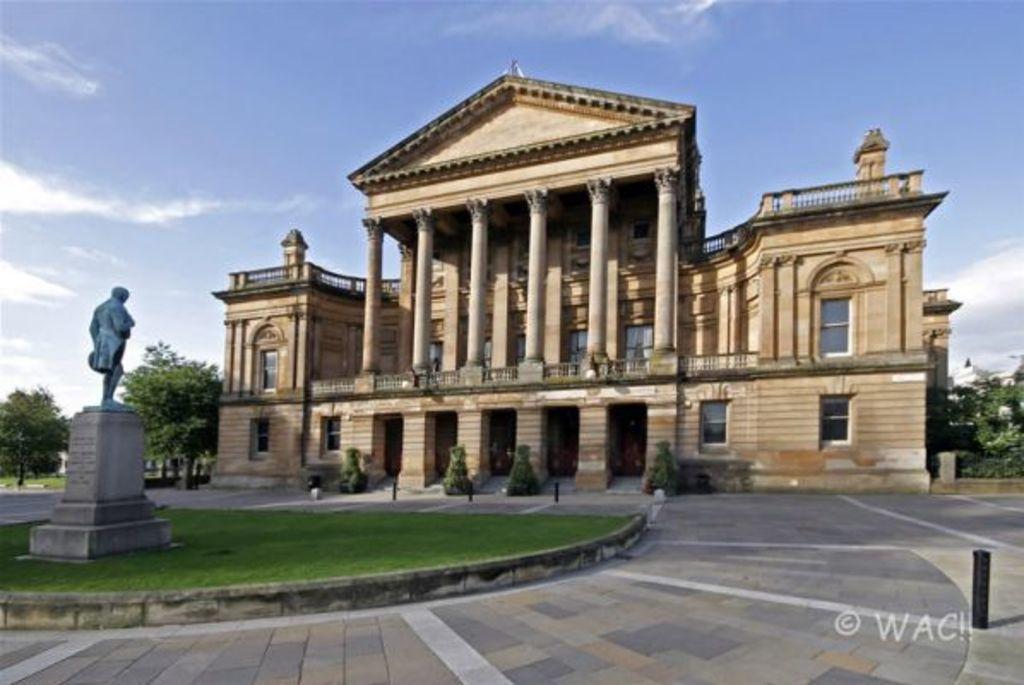Could you give a brief overview of what you see in this image? In this image we can see a building with pillars and windows. In front of the building there are bushes. On the left side there is a statue on a pedestal. Near to that there is grass on the ground. In the background there are trees and also there is sky with clouds. 